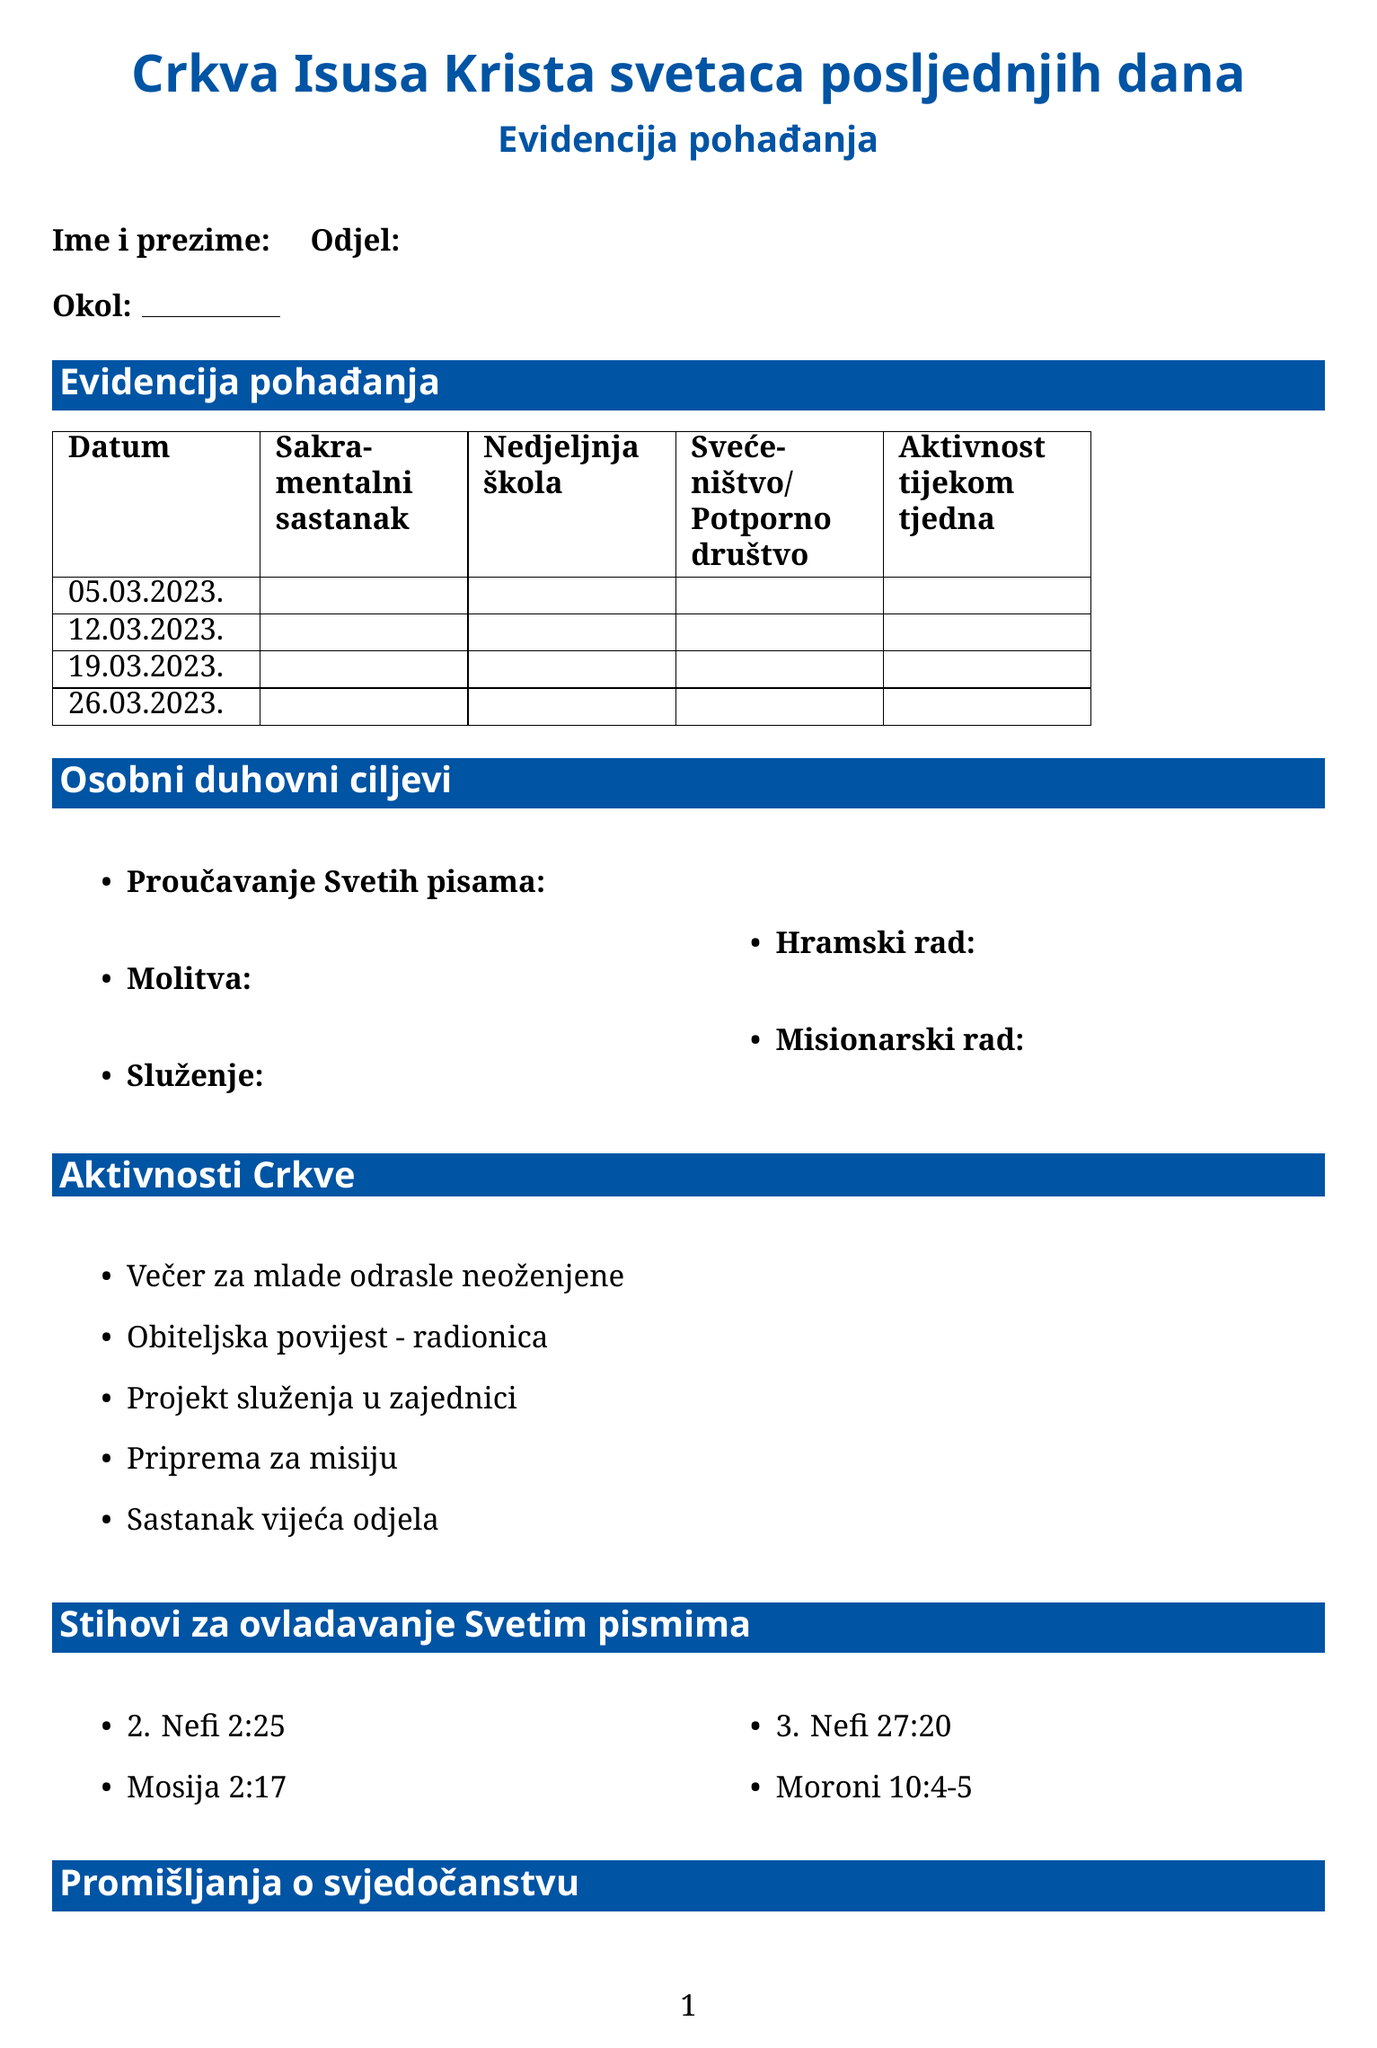What is the title of the form? The title of the form is indicated at the top of the document.
Answer: Evidencija pohađanja What date is listed first in the attendance table? The attendance table includes several sample dates at the beginning.
Answer: 05.03.2023 What are the five categories of personal spiritual goals? The document lists categories under personal spiritual goals.
Answer: Proučavanje Svetih pisama, Molitva, Služenje, Hramski rad, Misionarski rad How many scripture mastery verses are listed? The scripture mastery section contains a list of verses in the document.
Answer: 4 What is one church activity mentioned? The document provides a list of church activities.
Answer: Večer za mlade odrasle neoženjene What question prompt is about feeling the Spirit? One of the prompts under testimony reflections asks about the experience of the Spirit.
Answer: Kako sam osjetio/la Duha ovaj tjedan? In which month is the last sample date provided? The last sample date in the attendance table indicates the month.
Answer: Ožujak What is the stake referred to in the personal info section? The personal info section includes a space for the stake information.
Answer: Okol 